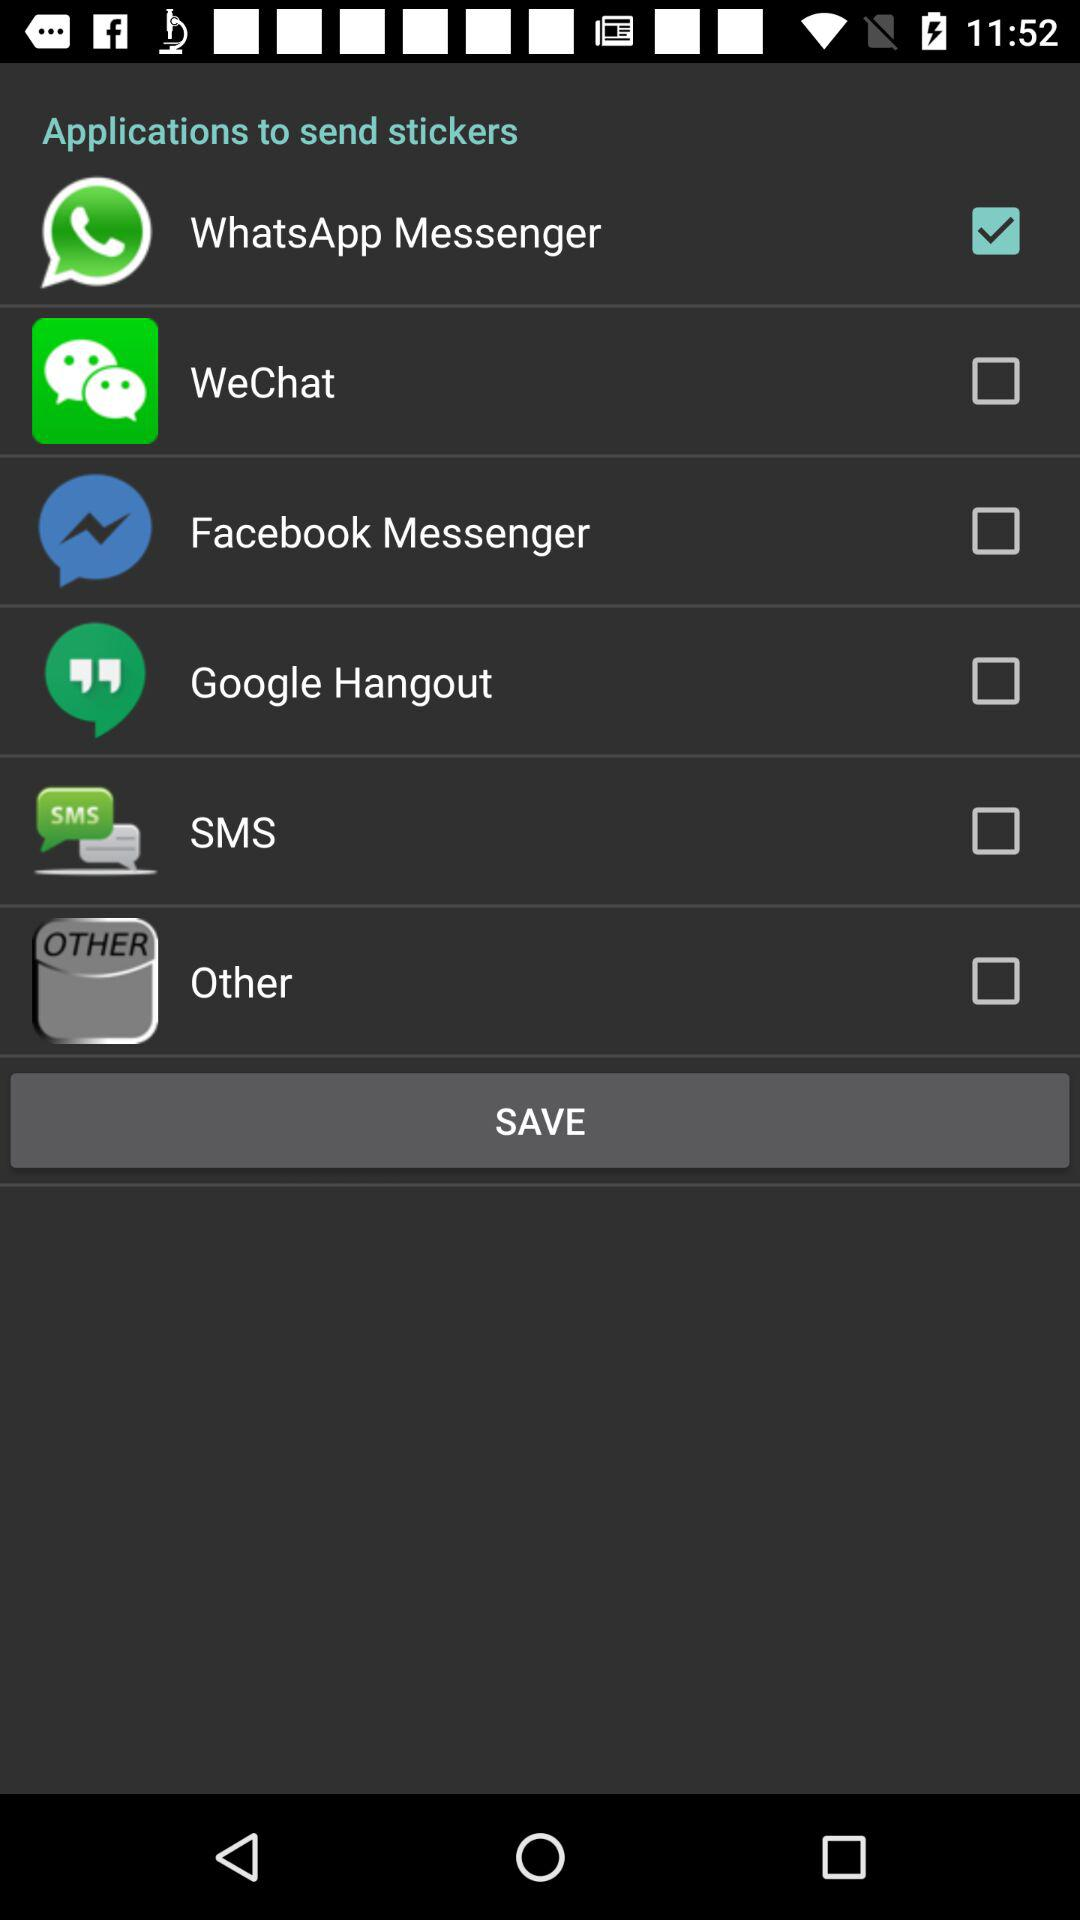What are the different applications available to send stickers? The different applications available to send stickers are "WhatsApp Messenger", "WeChat", "Facebook Messenger", "Google Hangout", "SMS" and "Other". 